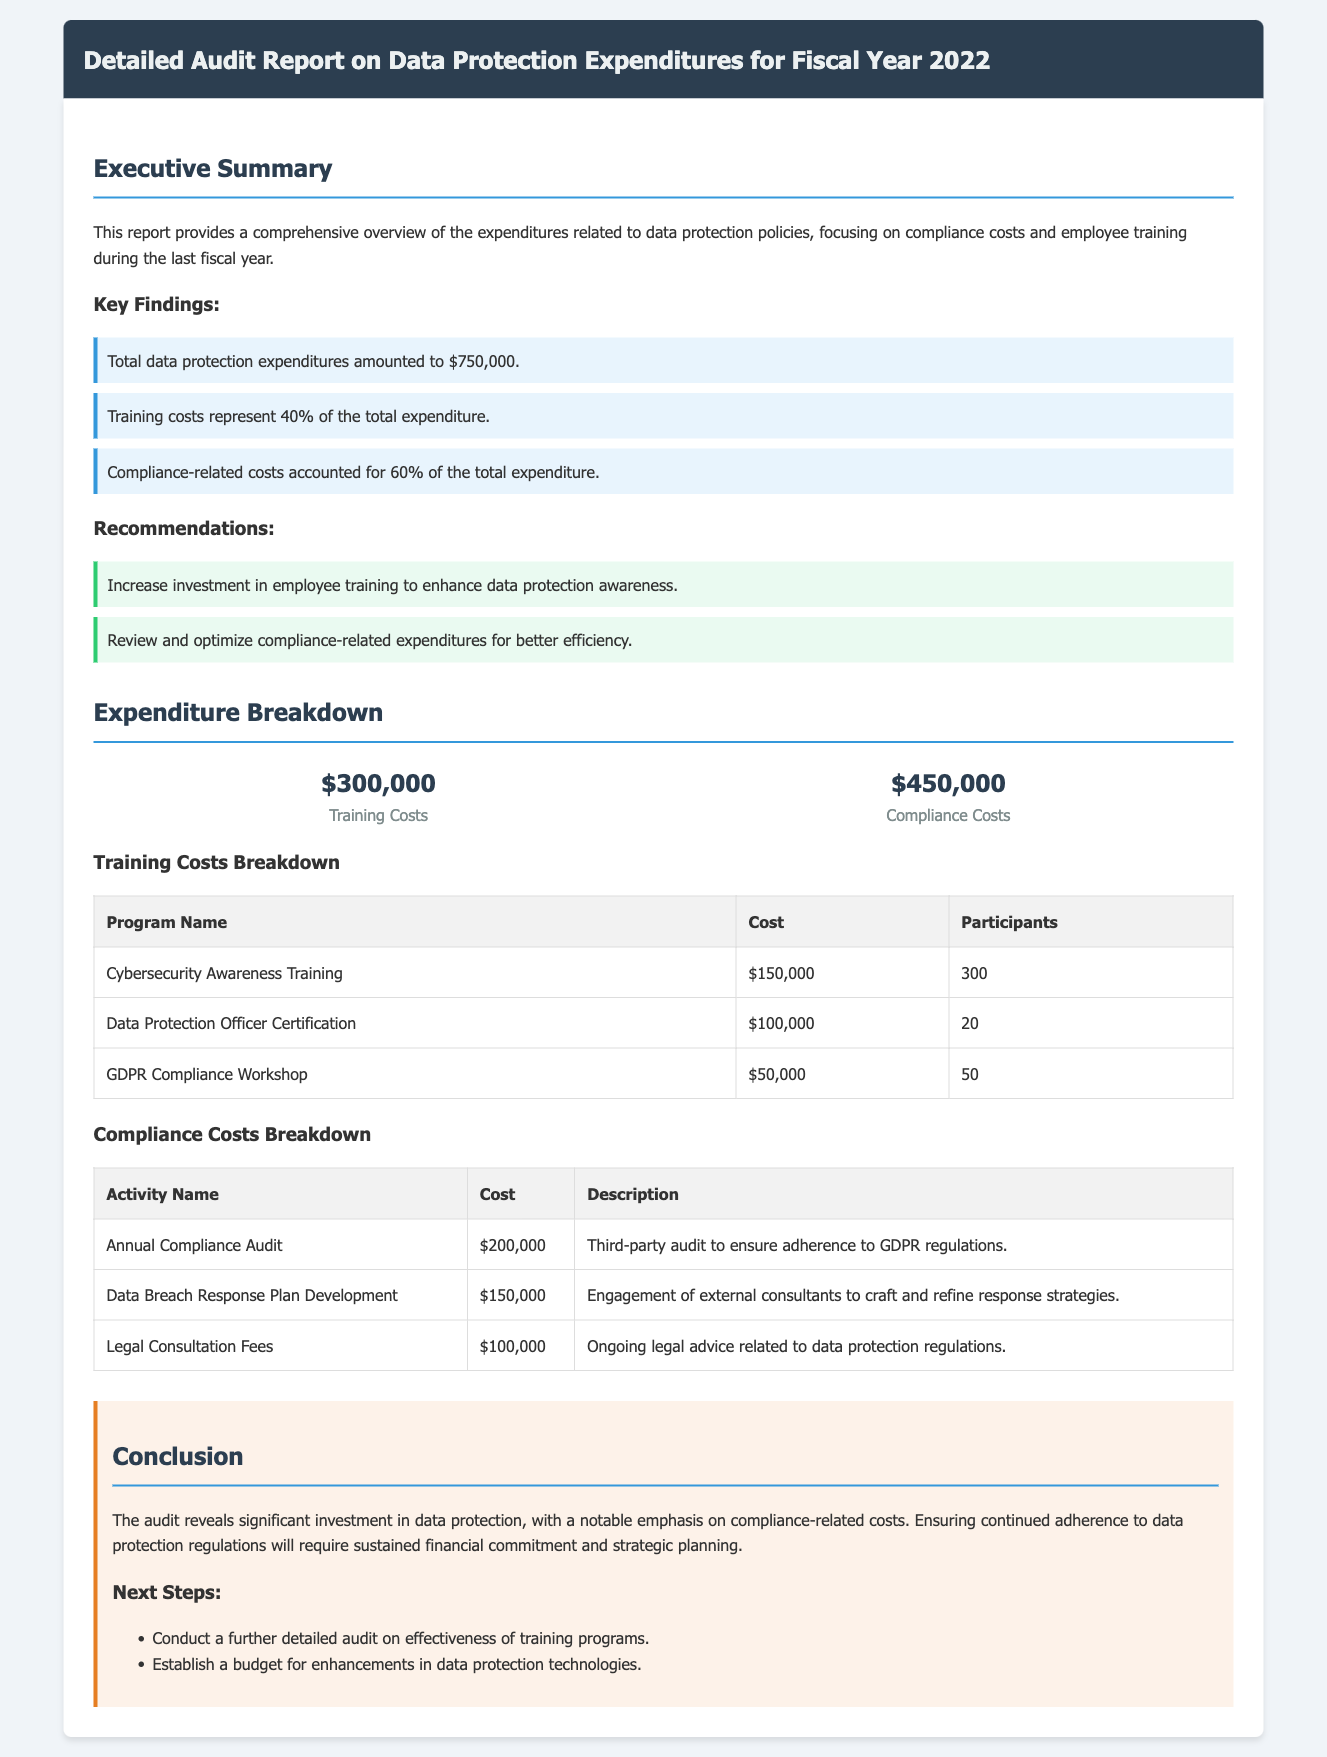What are the total data protection expenditures? The total data protection expenditures are mentioned in the document as a key finding.
Answer: $750,000 What percentage of the total expenditure is related to training costs? The document specifies that training costs are 40% of the total expenditure as a key finding.
Answer: 40% What was the cost of the Cybersecurity Awareness Training program? The cost is listed in the training costs breakdown table within the document.
Answer: $150,000 How much was spent on the Annual Compliance Audit? The document provides a specific cost for the Annual Compliance Audit in the compliance costs breakdown table.
Answer: $200,000 What recommendation is made regarding employee training? The report suggests a specific action regarding employee training as part of the recommendations section.
Answer: Increase investment in employee training What is the total cost of compliance-related expenditures? Compliance-related expenditures are calculated as a percentage of total expenditures, which is provided in the key findings.
Answer: $450,000 What was the number of participants in the Data Protection Officer Certification? The number of participants is detailed in the training costs breakdown table.
Answer: 20 What is the description of the Data Breach Response Plan Development activity? The description for this compliance-related activity is provided in the compliance costs breakdown table.
Answer: Engagement of external consultants to craft and refine response strategies What two next steps are outlined in the conclusion? The conclusion section lists specific next steps to be taken regarding data protection.
Answer: Conduct a further detailed audit on effectiveness of training programs. Establish a budget for enhancements in data protection technologies 